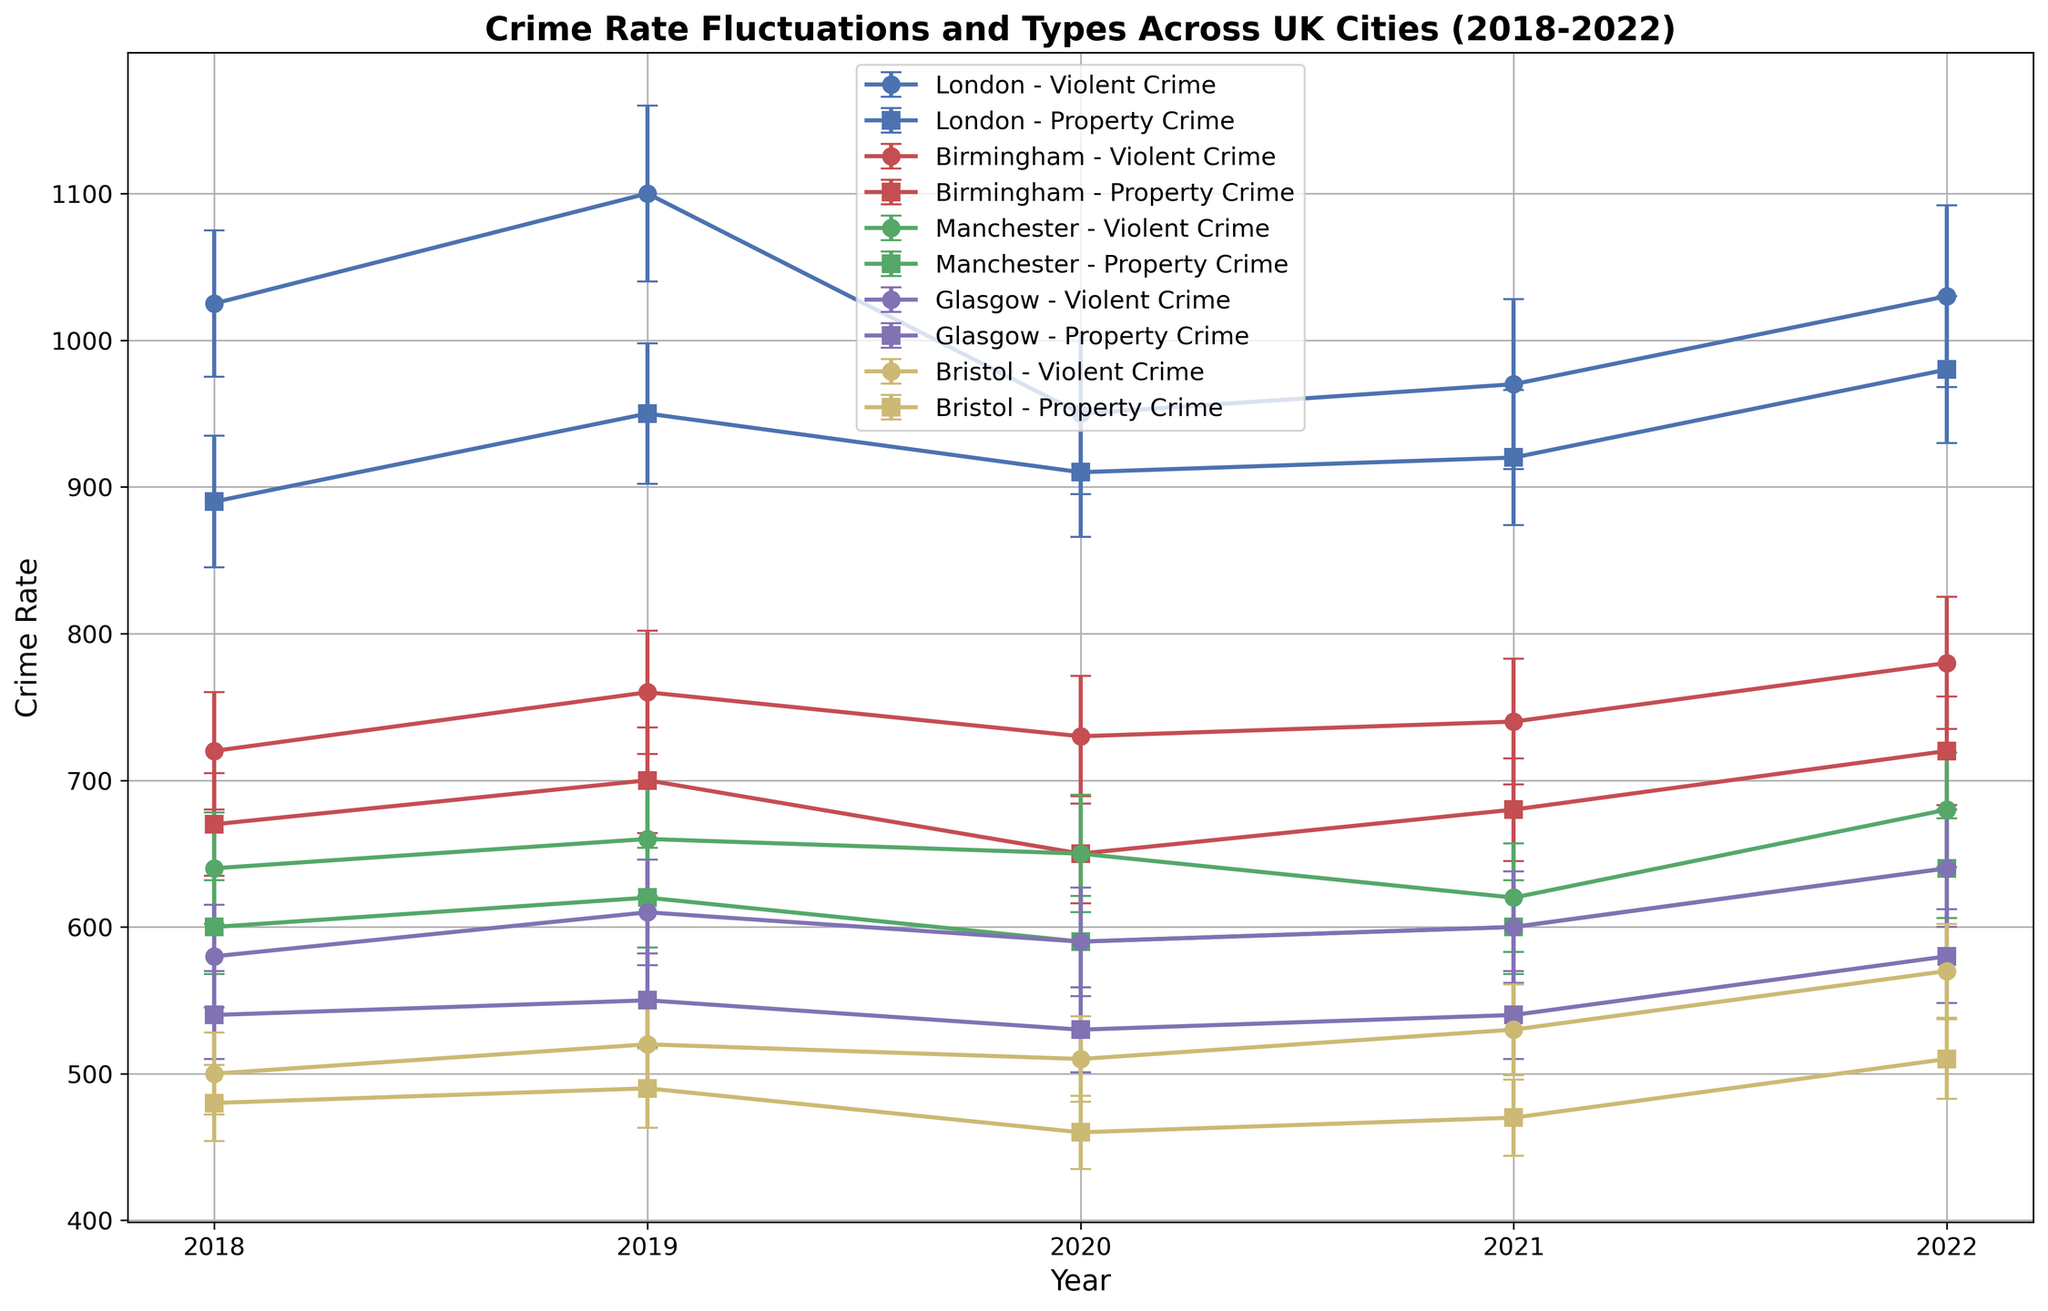Which city had the highest violent crime rate in 2022? Looking at the plot, identify the highest point within the series labeled "Violent Crime" for the year 2022. It's the city corresponding with the highest dot among violent crime series.
Answer: London What pattern do you notice in property crime rates in Bristol from 2018 to 2022? Observe the trend line for "Property Crime" in Bristol along with the markers. The line trend is generally increasing from its starting point in 2018 to its end point in 2022.
Answer: Increasing Compare the error bars for violent crime rates across all cities in 2020. Which city had the largest error? Error bars represent the uncertainty associated with the crime rate values. Identify the longest vertical line segment for "Violent Crime" in 2020.
Answer: London What is the average crime rate (mean) of property crimes in Manchester from 2018 to 2022? Add the property crime rates in Manchester for each year from 2018 to 2022 and divide by the number of years (5). \( \frac{(600 + 620 + 590 + 600 + 640)}{5} = \frac{3050}{5} \)
Answer: 610 How did violent crime rates in Glasgow change from 2018 to 2022? Follow the points connected by the line representing "Violent Crime" in Glasgow. Determine if the points rise, fall, or have any patterns. The trend is generally increasing.
Answer: Rising Which city showed the least fluctuation in property crime rates over the 5 years? Compare the property crime lines (connected markers) for each city and see which has the smallest range of values. The line that remains closest to a horizontal line indicates the least fluctuation.
Answer: Bristol Which city had a higher property crime rate in 2020: Glasgow or Bristol? Compare the heights of the two points labeled "Property Crime" for the year 2020 in Glasgow and Bristol respectively. The higher point corresponds to the city with the higher crime rate.
Answer: Glasgow Identify the year when Manchester experienced the lowest violent crime rate within the given period. Look at the series labeled "Violent Crime" for Manchester and find the point at the lowest position on the y-axis.
Answer: 2021 Determine the overall trend for violent crimes in Birmingham from 2018 to 2022. Connect the points of "Violent Crime" in Birmingham from 2018 to 2022 and observe the general direction of the line. Determine if it is moving up, down, or remaining constant.
Answer: Increasing 